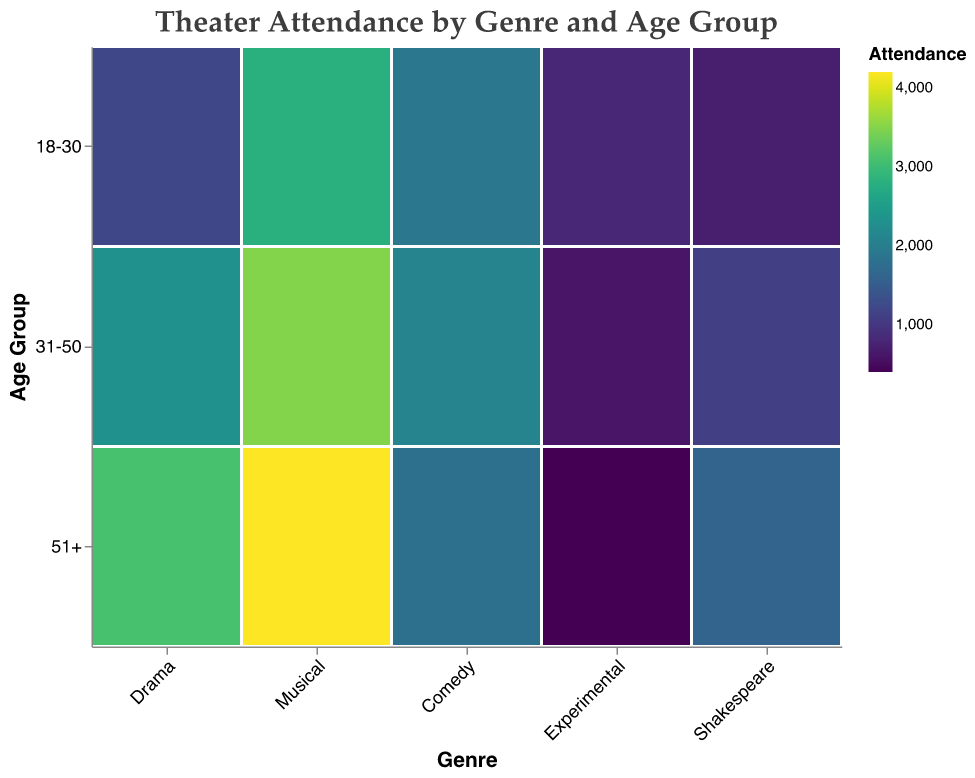Which genre has the highest attendance in the 51+ age group? By observing the figure, we look for the largest area/most intense color in the 51+ age group along the age axis, which corresponds to the musical genre.
Answer: Musical Which age group has the lowest attendance for Experimental theater? By looking at the rectangles for Experimental theater across different age groups, the smallest area/least intense color corresponds to the 51+ age group.
Answer: 51+ How does the attendance for Drama in the 31-50 age group compare to Comedy in the same age group? We examine the rectangles for Drama and Comedy in the 31-50 age group on the graph. Drama has a larger rectangle/a more intense color representation than Comedy.
Answer: Drama has higher attendance than Comedy in the 31-50 age group What is the combined attendance for Shakespeare for all age groups? We sum the attendance values for Shakespeare across all age groups: 700 (18-30) + 1100 (31-50) + 1600 (51+) = 3400.
Answer: 3400 Which genre shows the most uniform distribution across all age groups? By visualizing the distribution of attendance across each age group for every genre, Comedy shows fairly similar sized rectangles/intensity across all age groups indicating a more uniform distribution.
Answer: Comedy What is the difference in attendance between the 18-30 and 51+ age groups for Musicals? We subtract the attendance of the 18-30 age group from the 51+ age group for Musicals: 4200 (51+) - 2800 (18-30) = 1400.
Answer: 1400 Which age group generally attends the most theater performances? By visually comparing the size/intensity of rectangles across all genres and age groups, the 51+ age group has larger/more intense rectangles across most genres.
Answer: 51+ Which genre has the least attendance overall? By adding up the attendance numbers for each genre: Drama = 1200+2300+3100 = 6600, Musical = 2800+3500+4200 = 10500, Comedy = 1900+2100+1800 = 5800, Experimental = 800+600+400 = 1800, Shakespeare = 700+1100+1600 = 3400. Experimental has the least attendance overall.
Answer: Experimental Among the 18-30 age group, which genre has the second-highest attendance? We compare the attendance figures for the 18-30 age group: Drama (1200), Musical (2800), Comedy (1900), Experimental (800), Shakespeare (700). Comedy has the second-highest value after Musical.
Answer: Comedy 